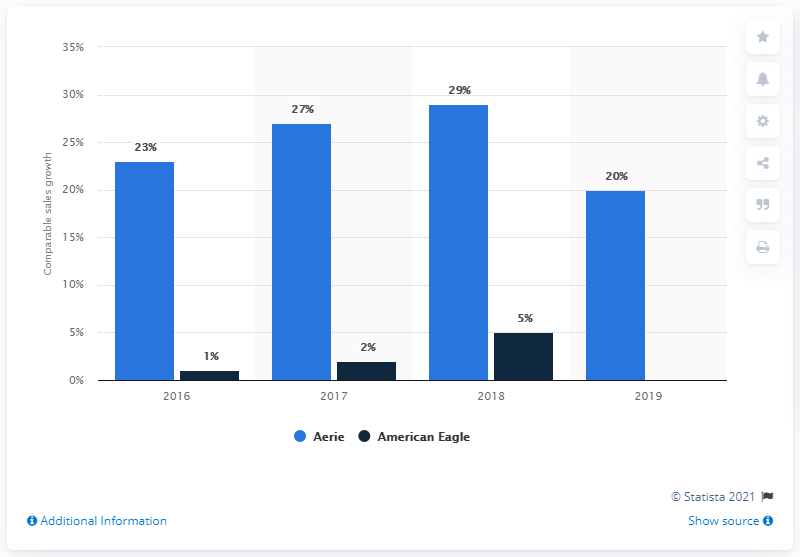What do the dark blue bars represent on this graph? The dark blue bars indicate the comparative sales growth percentage for American Eagle over the same time period, from 2016 to 2019. 